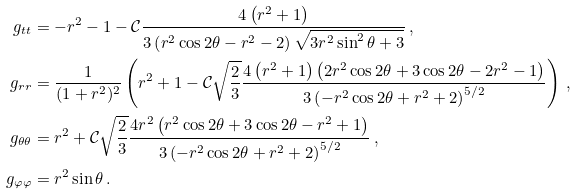<formula> <loc_0><loc_0><loc_500><loc_500>g _ { t t } & = - r ^ { 2 } - 1 - \mathcal { C } \frac { 4 \left ( r ^ { 2 } + 1 \right ) } { 3 \left ( r ^ { 2 } \cos { 2 \theta } - r ^ { 2 } - 2 \right ) \sqrt { 3 r ^ { 2 } \sin ^ { 2 } { \theta } + 3 } } \, , \\ g _ { r r } & = \frac { 1 } { ( 1 + r ^ { 2 } ) ^ { 2 } } \left ( r ^ { 2 } + 1 - \mathcal { C } \sqrt { \frac { 2 } { 3 } } \frac { 4 \left ( r ^ { 2 } + 1 \right ) \left ( 2 r ^ { 2 } \cos { 2 \theta } + 3 \cos { 2 \theta } - 2 r ^ { 2 } - 1 \right ) } { 3 \left ( - r ^ { 2 } \cos { 2 \theta } + r ^ { 2 } + 2 \right ) ^ { 5 / 2 } } \right ) \, , \\ g _ { \theta \theta } & = r ^ { 2 } + \mathcal { C } \sqrt { \frac { 2 } { 3 } } \frac { 4 r ^ { 2 } \left ( r ^ { 2 } \cos { 2 \theta } + 3 \cos { 2 \theta } - r ^ { 2 } + 1 \right ) } { 3 \left ( - r ^ { 2 } \cos { 2 \theta } + r ^ { 2 } + 2 \right ) ^ { 5 / 2 } } \, , \\ g _ { \varphi \varphi } & = r ^ { 2 } \sin { \theta } \, .</formula> 